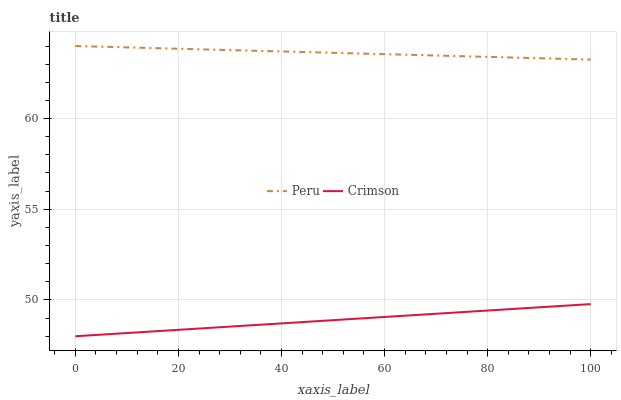Does Crimson have the minimum area under the curve?
Answer yes or no. Yes. Does Peru have the maximum area under the curve?
Answer yes or no. Yes. Does Peru have the minimum area under the curve?
Answer yes or no. No. Is Peru the smoothest?
Answer yes or no. Yes. Is Crimson the roughest?
Answer yes or no. Yes. Is Peru the roughest?
Answer yes or no. No. Does Crimson have the lowest value?
Answer yes or no. Yes. Does Peru have the lowest value?
Answer yes or no. No. Does Peru have the highest value?
Answer yes or no. Yes. Is Crimson less than Peru?
Answer yes or no. Yes. Is Peru greater than Crimson?
Answer yes or no. Yes. Does Crimson intersect Peru?
Answer yes or no. No. 